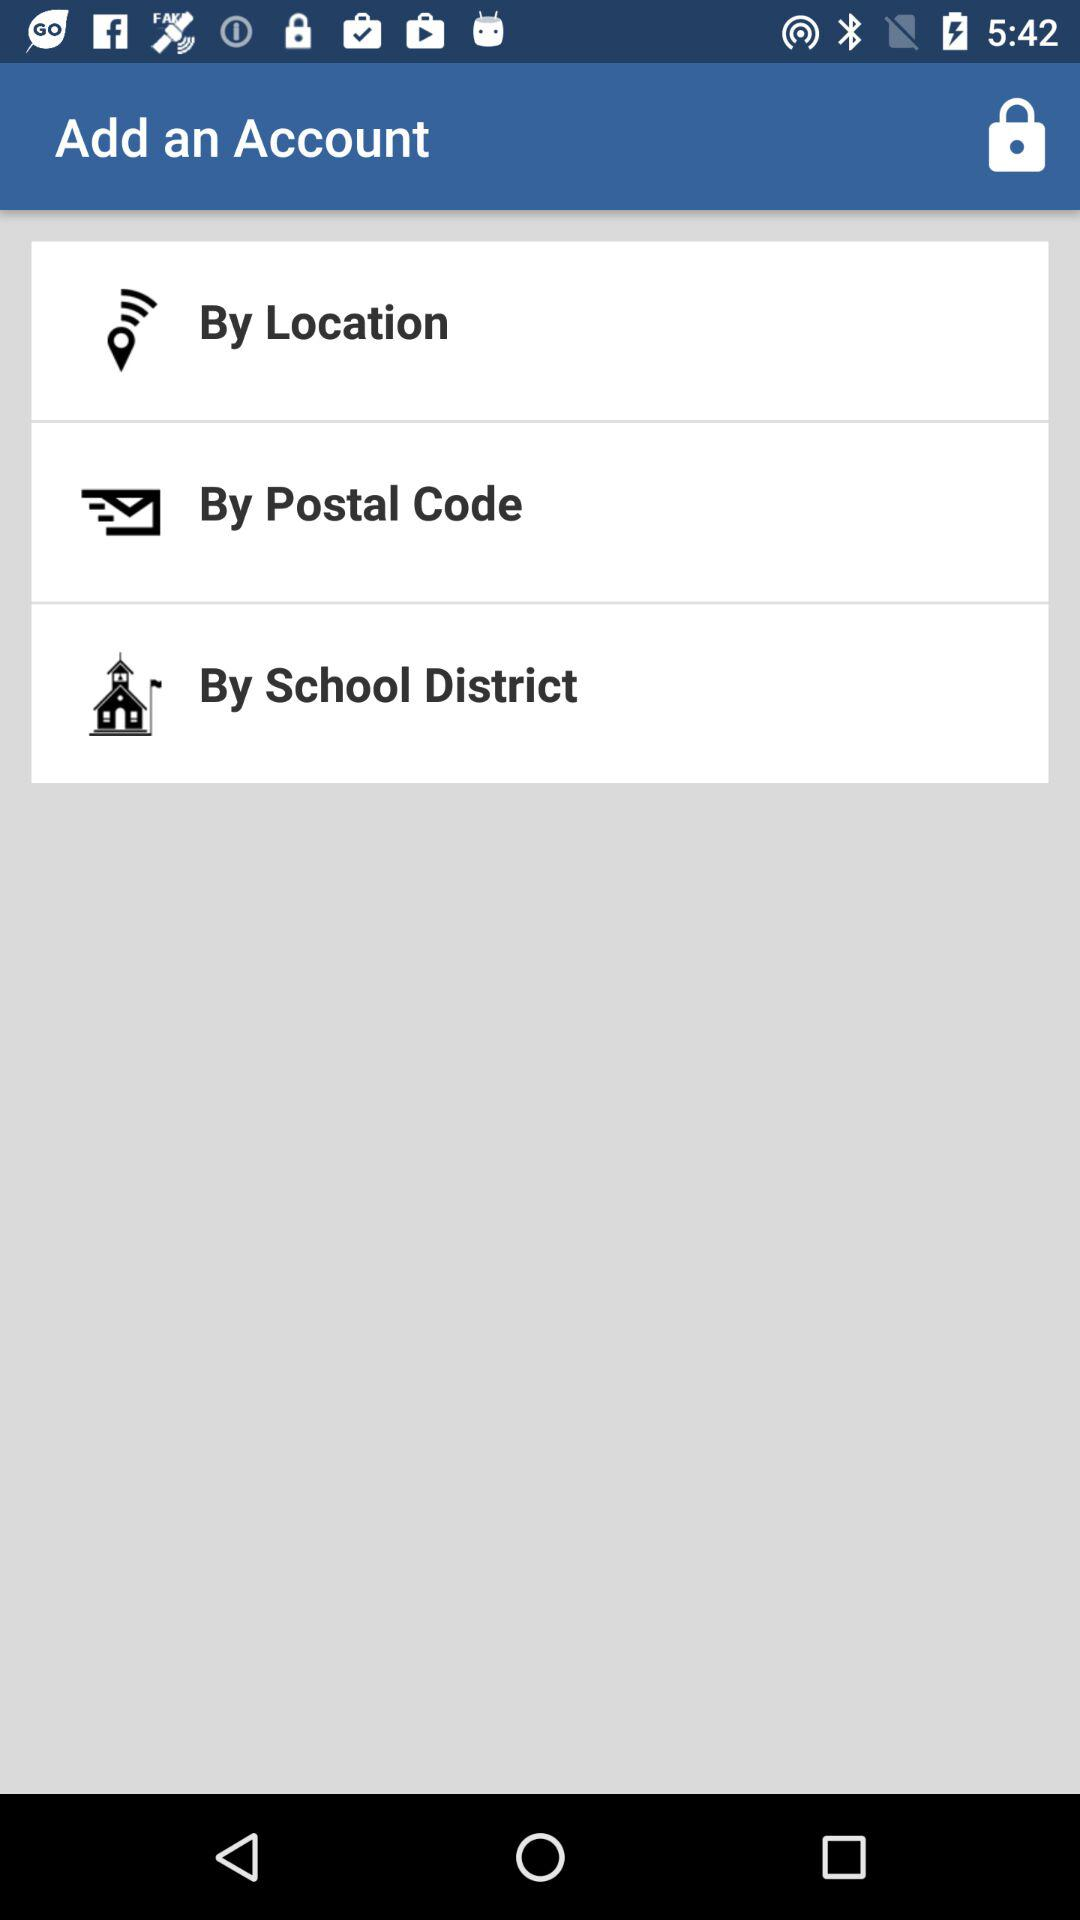What are the options available to add an account? The options available to add an account are "By Location", "By Postal Code" and "By School District". 